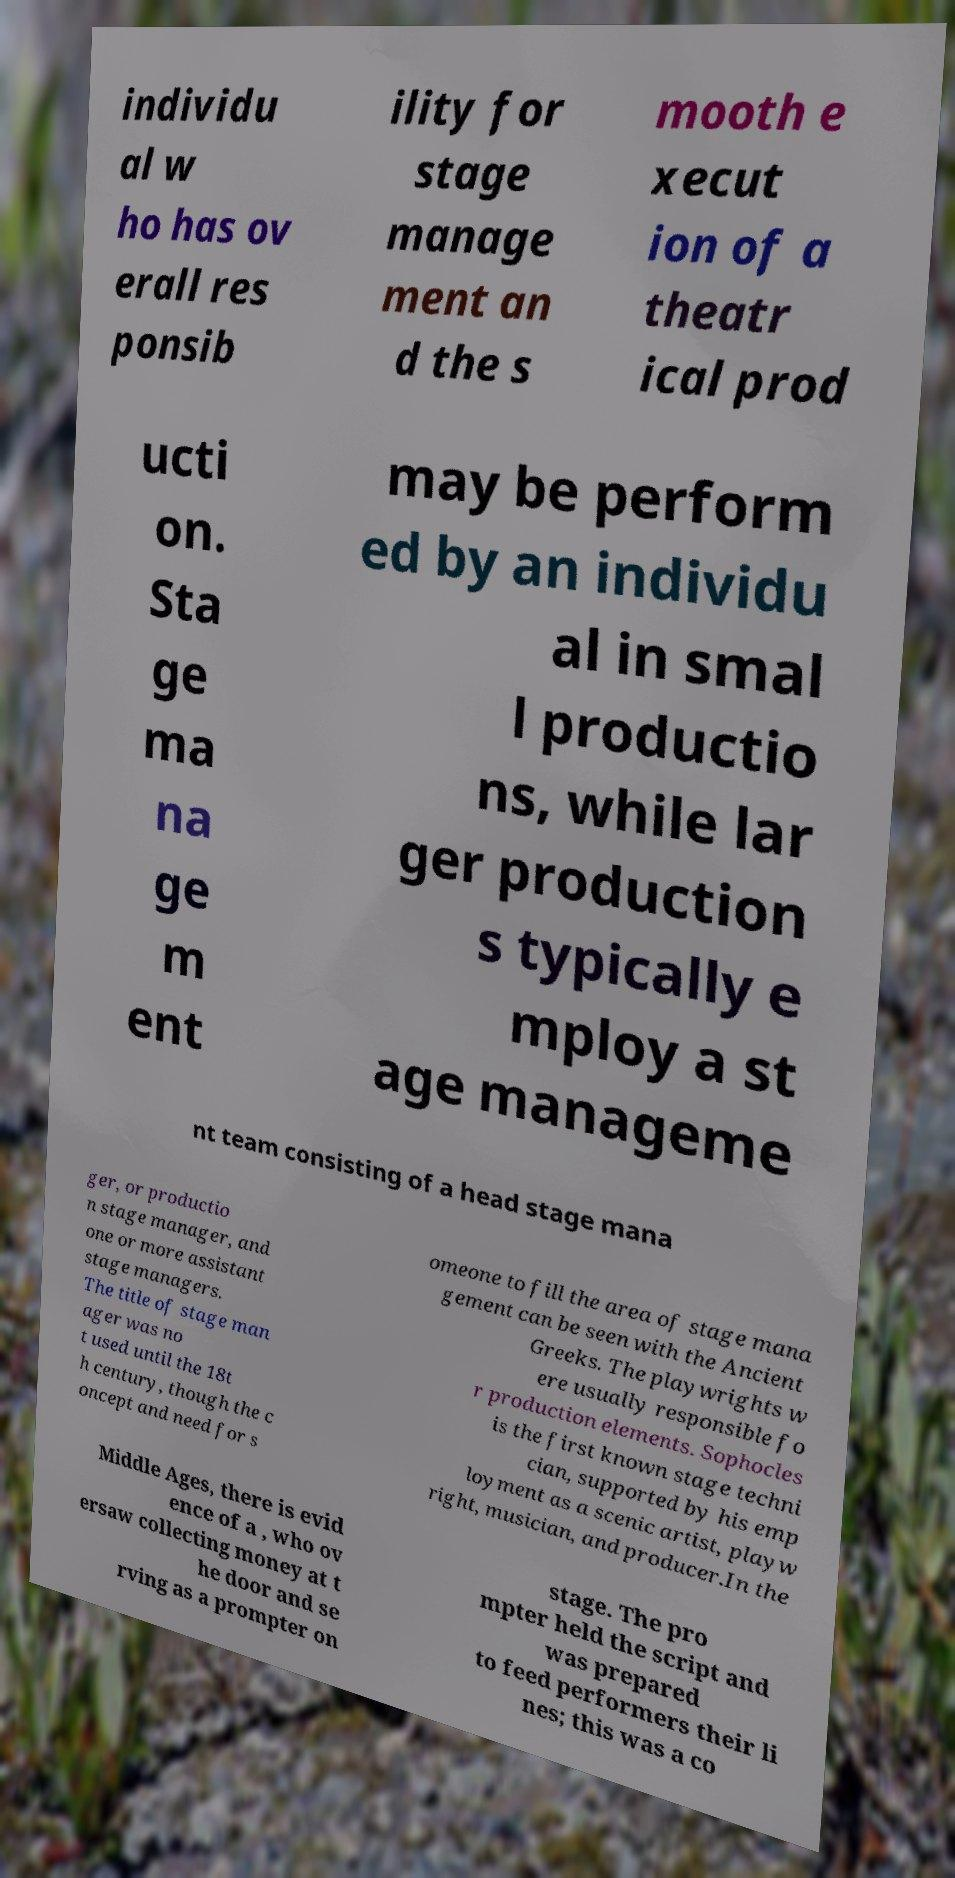Can you read and provide the text displayed in the image?This photo seems to have some interesting text. Can you extract and type it out for me? individu al w ho has ov erall res ponsib ility for stage manage ment an d the s mooth e xecut ion of a theatr ical prod ucti on. Sta ge ma na ge m ent may be perform ed by an individu al in smal l productio ns, while lar ger production s typically e mploy a st age manageme nt team consisting of a head stage mana ger, or productio n stage manager, and one or more assistant stage managers. The title of stage man ager was no t used until the 18t h century, though the c oncept and need for s omeone to fill the area of stage mana gement can be seen with the Ancient Greeks. The playwrights w ere usually responsible fo r production elements. Sophocles is the first known stage techni cian, supported by his emp loyment as a scenic artist, playw right, musician, and producer.In the Middle Ages, there is evid ence of a , who ov ersaw collecting money at t he door and se rving as a prompter on stage. The pro mpter held the script and was prepared to feed performers their li nes; this was a co 